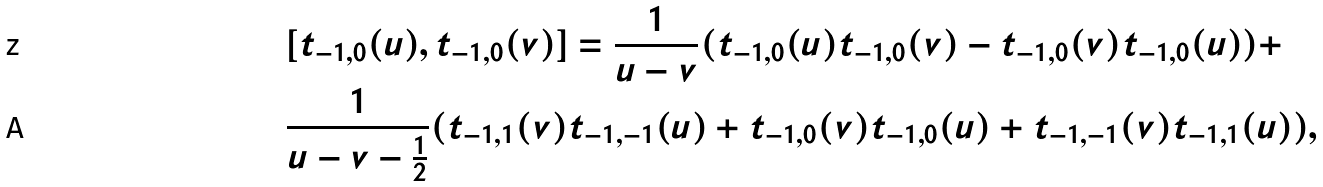<formula> <loc_0><loc_0><loc_500><loc_500>& [ t _ { - 1 , 0 } ( u ) , t _ { - 1 , 0 } ( v ) ] = \frac { 1 } { u - v } ( t _ { - 1 , 0 } ( u ) t _ { - 1 , 0 } ( v ) - t _ { - 1 , 0 } ( v ) t _ { - 1 , 0 } ( u ) ) + \\ & \frac { 1 } { u - v - \frac { 1 } { 2 } } ( t _ { - 1 , 1 } ( v ) t _ { - 1 , - 1 } ( u ) + t _ { - 1 , 0 } ( v ) t _ { - 1 , 0 } ( u ) + t _ { - 1 , - 1 } ( v ) t _ { - 1 , 1 } ( u ) ) ,</formula> 